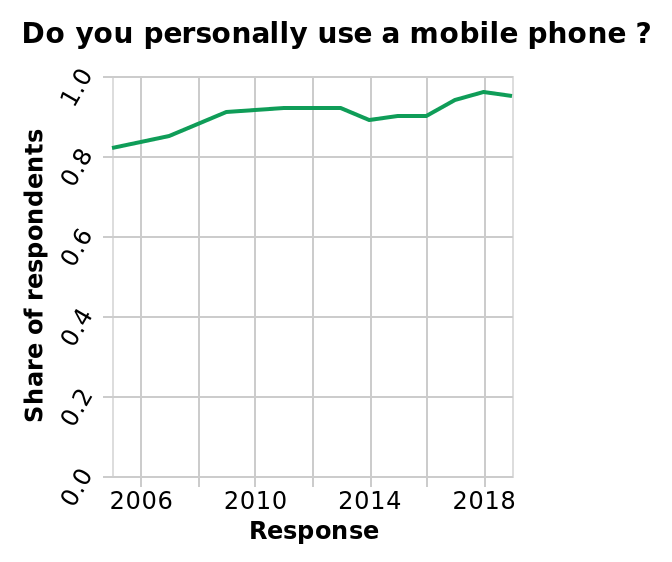<image>
Offer a thorough analysis of the image. The number of people who responded that are using a mobile phone has generally moved upwards over the time period in question. What does the y-axis represent in the line graph?  The y-axis represents the share of respondents, ranging from 0.0 to 1.0. 